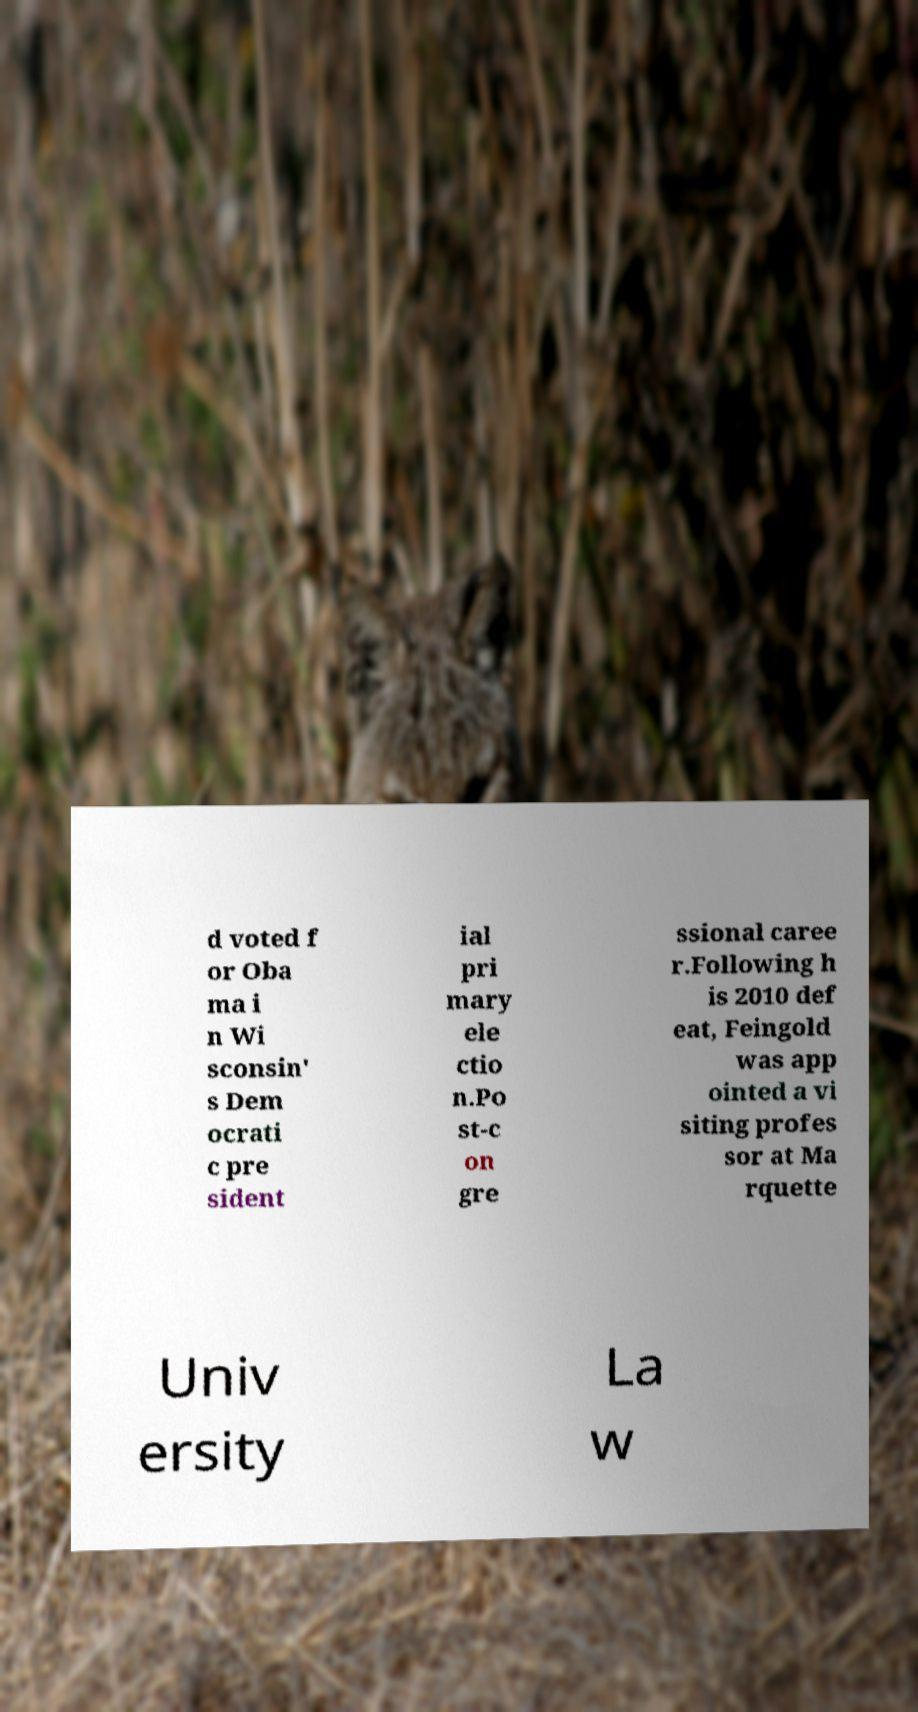Can you accurately transcribe the text from the provided image for me? d voted f or Oba ma i n Wi sconsin' s Dem ocrati c pre sident ial pri mary ele ctio n.Po st-c on gre ssional caree r.Following h is 2010 def eat, Feingold was app ointed a vi siting profes sor at Ma rquette Univ ersity La w 